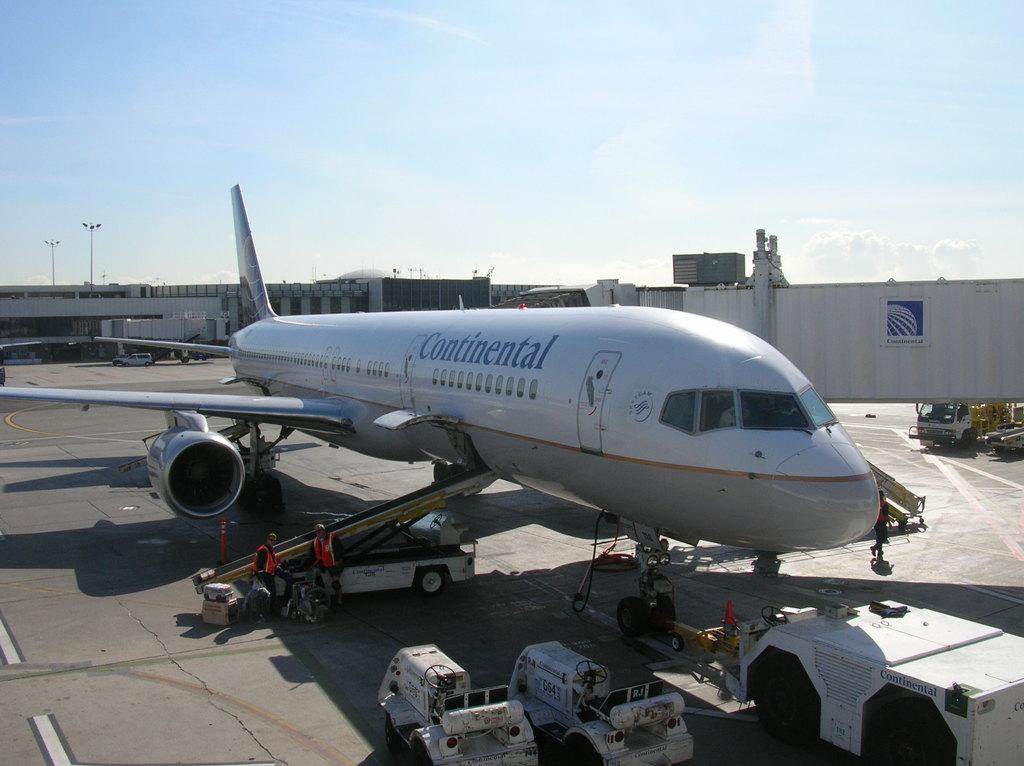Is that a continental plane?
Ensure brevity in your answer.  Yes. What airline is this?
Offer a terse response. Continental. 